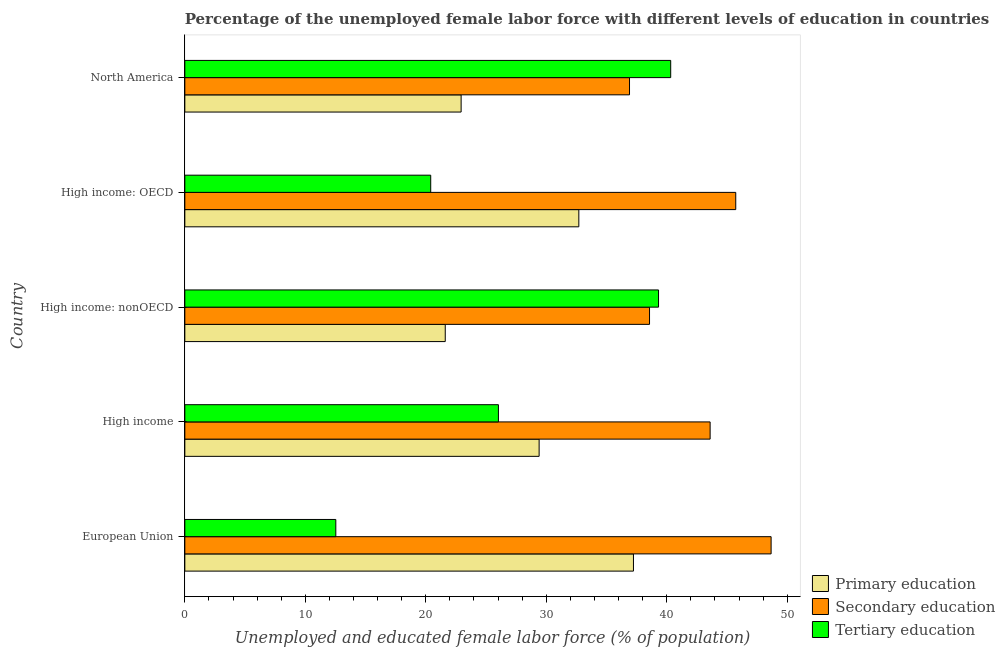How many different coloured bars are there?
Your answer should be compact. 3. Are the number of bars on each tick of the Y-axis equal?
Provide a succinct answer. Yes. How many bars are there on the 2nd tick from the top?
Provide a succinct answer. 3. How many bars are there on the 1st tick from the bottom?
Give a very brief answer. 3. What is the label of the 2nd group of bars from the top?
Your answer should be compact. High income: OECD. What is the percentage of female labor force who received secondary education in High income: OECD?
Offer a terse response. 45.73. Across all countries, what is the maximum percentage of female labor force who received tertiary education?
Offer a very short reply. 40.33. Across all countries, what is the minimum percentage of female labor force who received primary education?
Your response must be concise. 21.62. In which country was the percentage of female labor force who received secondary education maximum?
Your response must be concise. European Union. What is the total percentage of female labor force who received primary education in the graph?
Provide a short and direct response. 143.89. What is the difference between the percentage of female labor force who received primary education in European Union and that in High income: OECD?
Offer a terse response. 4.54. What is the difference between the percentage of female labor force who received tertiary education in High income and the percentage of female labor force who received secondary education in European Union?
Your answer should be very brief. -22.63. What is the average percentage of female labor force who received secondary education per country?
Your answer should be very brief. 42.69. What is the difference between the percentage of female labor force who received tertiary education and percentage of female labor force who received secondary education in European Union?
Your answer should be very brief. -36.13. What is the ratio of the percentage of female labor force who received tertiary education in European Union to that in High income: OECD?
Offer a terse response. 0.61. Is the percentage of female labor force who received secondary education in High income less than that in High income: OECD?
Provide a succinct answer. Yes. Is the difference between the percentage of female labor force who received primary education in High income and High income: nonOECD greater than the difference between the percentage of female labor force who received tertiary education in High income and High income: nonOECD?
Provide a short and direct response. Yes. What is the difference between the highest and the second highest percentage of female labor force who received secondary education?
Provide a short and direct response. 2.94. What is the difference between the highest and the lowest percentage of female labor force who received tertiary education?
Your response must be concise. 27.8. Is the sum of the percentage of female labor force who received primary education in High income and North America greater than the maximum percentage of female labor force who received secondary education across all countries?
Ensure brevity in your answer.  Yes. What does the 3rd bar from the bottom in High income: OECD represents?
Make the answer very short. Tertiary education. Is it the case that in every country, the sum of the percentage of female labor force who received primary education and percentage of female labor force who received secondary education is greater than the percentage of female labor force who received tertiary education?
Your answer should be compact. Yes. Are all the bars in the graph horizontal?
Give a very brief answer. Yes. What is the difference between two consecutive major ticks on the X-axis?
Offer a terse response. 10. Does the graph contain any zero values?
Keep it short and to the point. No. Does the graph contain grids?
Keep it short and to the point. No. Where does the legend appear in the graph?
Your response must be concise. Bottom right. What is the title of the graph?
Provide a succinct answer. Percentage of the unemployed female labor force with different levels of education in countries. What is the label or title of the X-axis?
Provide a succinct answer. Unemployed and educated female labor force (% of population). What is the label or title of the Y-axis?
Your answer should be compact. Country. What is the Unemployed and educated female labor force (% of population) in Primary education in European Union?
Provide a succinct answer. 37.24. What is the Unemployed and educated female labor force (% of population) in Secondary education in European Union?
Your answer should be compact. 48.66. What is the Unemployed and educated female labor force (% of population) of Tertiary education in European Union?
Ensure brevity in your answer.  12.53. What is the Unemployed and educated female labor force (% of population) of Primary education in High income?
Your response must be concise. 29.41. What is the Unemployed and educated female labor force (% of population) of Secondary education in High income?
Offer a very short reply. 43.6. What is the Unemployed and educated female labor force (% of population) of Tertiary education in High income?
Give a very brief answer. 26.03. What is the Unemployed and educated female labor force (% of population) in Primary education in High income: nonOECD?
Ensure brevity in your answer.  21.62. What is the Unemployed and educated female labor force (% of population) in Secondary education in High income: nonOECD?
Offer a terse response. 38.57. What is the Unemployed and educated female labor force (% of population) in Tertiary education in High income: nonOECD?
Offer a very short reply. 39.32. What is the Unemployed and educated female labor force (% of population) of Primary education in High income: OECD?
Make the answer very short. 32.7. What is the Unemployed and educated female labor force (% of population) in Secondary education in High income: OECD?
Give a very brief answer. 45.73. What is the Unemployed and educated female labor force (% of population) of Tertiary education in High income: OECD?
Provide a short and direct response. 20.41. What is the Unemployed and educated female labor force (% of population) in Primary education in North America?
Give a very brief answer. 22.93. What is the Unemployed and educated female labor force (% of population) of Secondary education in North America?
Provide a succinct answer. 36.91. What is the Unemployed and educated female labor force (% of population) of Tertiary education in North America?
Ensure brevity in your answer.  40.33. Across all countries, what is the maximum Unemployed and educated female labor force (% of population) of Primary education?
Ensure brevity in your answer.  37.24. Across all countries, what is the maximum Unemployed and educated female labor force (% of population) of Secondary education?
Your response must be concise. 48.66. Across all countries, what is the maximum Unemployed and educated female labor force (% of population) of Tertiary education?
Your response must be concise. 40.33. Across all countries, what is the minimum Unemployed and educated female labor force (% of population) in Primary education?
Ensure brevity in your answer.  21.62. Across all countries, what is the minimum Unemployed and educated female labor force (% of population) in Secondary education?
Your response must be concise. 36.91. Across all countries, what is the minimum Unemployed and educated female labor force (% of population) of Tertiary education?
Offer a terse response. 12.53. What is the total Unemployed and educated female labor force (% of population) of Primary education in the graph?
Keep it short and to the point. 143.89. What is the total Unemployed and educated female labor force (% of population) in Secondary education in the graph?
Keep it short and to the point. 213.47. What is the total Unemployed and educated female labor force (% of population) of Tertiary education in the graph?
Ensure brevity in your answer.  138.61. What is the difference between the Unemployed and educated female labor force (% of population) of Primary education in European Union and that in High income?
Provide a short and direct response. 7.83. What is the difference between the Unemployed and educated female labor force (% of population) in Secondary education in European Union and that in High income?
Your answer should be very brief. 5.06. What is the difference between the Unemployed and educated female labor force (% of population) of Tertiary education in European Union and that in High income?
Your response must be concise. -13.5. What is the difference between the Unemployed and educated female labor force (% of population) of Primary education in European Union and that in High income: nonOECD?
Your answer should be compact. 15.62. What is the difference between the Unemployed and educated female labor force (% of population) in Secondary education in European Union and that in High income: nonOECD?
Your response must be concise. 10.09. What is the difference between the Unemployed and educated female labor force (% of population) in Tertiary education in European Union and that in High income: nonOECD?
Offer a terse response. -26.79. What is the difference between the Unemployed and educated female labor force (% of population) of Primary education in European Union and that in High income: OECD?
Offer a terse response. 4.53. What is the difference between the Unemployed and educated female labor force (% of population) in Secondary education in European Union and that in High income: OECD?
Your response must be concise. 2.94. What is the difference between the Unemployed and educated female labor force (% of population) of Tertiary education in European Union and that in High income: OECD?
Ensure brevity in your answer.  -7.88. What is the difference between the Unemployed and educated female labor force (% of population) of Primary education in European Union and that in North America?
Offer a very short reply. 14.3. What is the difference between the Unemployed and educated female labor force (% of population) of Secondary education in European Union and that in North America?
Offer a very short reply. 11.75. What is the difference between the Unemployed and educated female labor force (% of population) in Tertiary education in European Union and that in North America?
Your response must be concise. -27.8. What is the difference between the Unemployed and educated female labor force (% of population) in Primary education in High income and that in High income: nonOECD?
Your answer should be very brief. 7.79. What is the difference between the Unemployed and educated female labor force (% of population) in Secondary education in High income and that in High income: nonOECD?
Give a very brief answer. 5.03. What is the difference between the Unemployed and educated female labor force (% of population) of Tertiary education in High income and that in High income: nonOECD?
Provide a short and direct response. -13.29. What is the difference between the Unemployed and educated female labor force (% of population) in Primary education in High income and that in High income: OECD?
Your response must be concise. -3.29. What is the difference between the Unemployed and educated female labor force (% of population) in Secondary education in High income and that in High income: OECD?
Offer a terse response. -2.13. What is the difference between the Unemployed and educated female labor force (% of population) of Tertiary education in High income and that in High income: OECD?
Provide a short and direct response. 5.62. What is the difference between the Unemployed and educated female labor force (% of population) in Primary education in High income and that in North America?
Offer a very short reply. 6.47. What is the difference between the Unemployed and educated female labor force (% of population) in Secondary education in High income and that in North America?
Offer a terse response. 6.69. What is the difference between the Unemployed and educated female labor force (% of population) of Tertiary education in High income and that in North America?
Ensure brevity in your answer.  -14.3. What is the difference between the Unemployed and educated female labor force (% of population) in Primary education in High income: nonOECD and that in High income: OECD?
Your answer should be very brief. -11.09. What is the difference between the Unemployed and educated female labor force (% of population) in Secondary education in High income: nonOECD and that in High income: OECD?
Your answer should be compact. -7.16. What is the difference between the Unemployed and educated female labor force (% of population) in Tertiary education in High income: nonOECD and that in High income: OECD?
Ensure brevity in your answer.  18.91. What is the difference between the Unemployed and educated female labor force (% of population) in Primary education in High income: nonOECD and that in North America?
Make the answer very short. -1.32. What is the difference between the Unemployed and educated female labor force (% of population) of Secondary education in High income: nonOECD and that in North America?
Offer a terse response. 1.66. What is the difference between the Unemployed and educated female labor force (% of population) in Tertiary education in High income: nonOECD and that in North America?
Offer a very short reply. -1.01. What is the difference between the Unemployed and educated female labor force (% of population) of Primary education in High income: OECD and that in North America?
Give a very brief answer. 9.77. What is the difference between the Unemployed and educated female labor force (% of population) in Secondary education in High income: OECD and that in North America?
Offer a terse response. 8.82. What is the difference between the Unemployed and educated female labor force (% of population) in Tertiary education in High income: OECD and that in North America?
Offer a terse response. -19.92. What is the difference between the Unemployed and educated female labor force (% of population) of Primary education in European Union and the Unemployed and educated female labor force (% of population) of Secondary education in High income?
Make the answer very short. -6.36. What is the difference between the Unemployed and educated female labor force (% of population) of Primary education in European Union and the Unemployed and educated female labor force (% of population) of Tertiary education in High income?
Make the answer very short. 11.21. What is the difference between the Unemployed and educated female labor force (% of population) of Secondary education in European Union and the Unemployed and educated female labor force (% of population) of Tertiary education in High income?
Keep it short and to the point. 22.63. What is the difference between the Unemployed and educated female labor force (% of population) in Primary education in European Union and the Unemployed and educated female labor force (% of population) in Secondary education in High income: nonOECD?
Keep it short and to the point. -1.33. What is the difference between the Unemployed and educated female labor force (% of population) of Primary education in European Union and the Unemployed and educated female labor force (% of population) of Tertiary education in High income: nonOECD?
Provide a short and direct response. -2.08. What is the difference between the Unemployed and educated female labor force (% of population) in Secondary education in European Union and the Unemployed and educated female labor force (% of population) in Tertiary education in High income: nonOECD?
Keep it short and to the point. 9.34. What is the difference between the Unemployed and educated female labor force (% of population) of Primary education in European Union and the Unemployed and educated female labor force (% of population) of Secondary education in High income: OECD?
Provide a succinct answer. -8.49. What is the difference between the Unemployed and educated female labor force (% of population) of Primary education in European Union and the Unemployed and educated female labor force (% of population) of Tertiary education in High income: OECD?
Your answer should be very brief. 16.83. What is the difference between the Unemployed and educated female labor force (% of population) of Secondary education in European Union and the Unemployed and educated female labor force (% of population) of Tertiary education in High income: OECD?
Offer a very short reply. 28.25. What is the difference between the Unemployed and educated female labor force (% of population) of Primary education in European Union and the Unemployed and educated female labor force (% of population) of Secondary education in North America?
Make the answer very short. 0.33. What is the difference between the Unemployed and educated female labor force (% of population) of Primary education in European Union and the Unemployed and educated female labor force (% of population) of Tertiary education in North America?
Your answer should be very brief. -3.09. What is the difference between the Unemployed and educated female labor force (% of population) of Secondary education in European Union and the Unemployed and educated female labor force (% of population) of Tertiary education in North America?
Your answer should be very brief. 8.33. What is the difference between the Unemployed and educated female labor force (% of population) of Primary education in High income and the Unemployed and educated female labor force (% of population) of Secondary education in High income: nonOECD?
Make the answer very short. -9.16. What is the difference between the Unemployed and educated female labor force (% of population) in Primary education in High income and the Unemployed and educated female labor force (% of population) in Tertiary education in High income: nonOECD?
Give a very brief answer. -9.91. What is the difference between the Unemployed and educated female labor force (% of population) of Secondary education in High income and the Unemployed and educated female labor force (% of population) of Tertiary education in High income: nonOECD?
Provide a short and direct response. 4.28. What is the difference between the Unemployed and educated female labor force (% of population) of Primary education in High income and the Unemployed and educated female labor force (% of population) of Secondary education in High income: OECD?
Give a very brief answer. -16.32. What is the difference between the Unemployed and educated female labor force (% of population) in Primary education in High income and the Unemployed and educated female labor force (% of population) in Tertiary education in High income: OECD?
Offer a very short reply. 9. What is the difference between the Unemployed and educated female labor force (% of population) in Secondary education in High income and the Unemployed and educated female labor force (% of population) in Tertiary education in High income: OECD?
Provide a succinct answer. 23.19. What is the difference between the Unemployed and educated female labor force (% of population) in Primary education in High income and the Unemployed and educated female labor force (% of population) in Secondary education in North America?
Give a very brief answer. -7.5. What is the difference between the Unemployed and educated female labor force (% of population) of Primary education in High income and the Unemployed and educated female labor force (% of population) of Tertiary education in North America?
Offer a very short reply. -10.92. What is the difference between the Unemployed and educated female labor force (% of population) of Secondary education in High income and the Unemployed and educated female labor force (% of population) of Tertiary education in North America?
Your response must be concise. 3.27. What is the difference between the Unemployed and educated female labor force (% of population) in Primary education in High income: nonOECD and the Unemployed and educated female labor force (% of population) in Secondary education in High income: OECD?
Ensure brevity in your answer.  -24.11. What is the difference between the Unemployed and educated female labor force (% of population) in Primary education in High income: nonOECD and the Unemployed and educated female labor force (% of population) in Tertiary education in High income: OECD?
Provide a succinct answer. 1.21. What is the difference between the Unemployed and educated female labor force (% of population) of Secondary education in High income: nonOECD and the Unemployed and educated female labor force (% of population) of Tertiary education in High income: OECD?
Provide a succinct answer. 18.16. What is the difference between the Unemployed and educated female labor force (% of population) in Primary education in High income: nonOECD and the Unemployed and educated female labor force (% of population) in Secondary education in North America?
Give a very brief answer. -15.29. What is the difference between the Unemployed and educated female labor force (% of population) in Primary education in High income: nonOECD and the Unemployed and educated female labor force (% of population) in Tertiary education in North America?
Provide a short and direct response. -18.71. What is the difference between the Unemployed and educated female labor force (% of population) in Secondary education in High income: nonOECD and the Unemployed and educated female labor force (% of population) in Tertiary education in North America?
Make the answer very short. -1.76. What is the difference between the Unemployed and educated female labor force (% of population) of Primary education in High income: OECD and the Unemployed and educated female labor force (% of population) of Secondary education in North America?
Make the answer very short. -4.21. What is the difference between the Unemployed and educated female labor force (% of population) of Primary education in High income: OECD and the Unemployed and educated female labor force (% of population) of Tertiary education in North America?
Ensure brevity in your answer.  -7.63. What is the difference between the Unemployed and educated female labor force (% of population) in Secondary education in High income: OECD and the Unemployed and educated female labor force (% of population) in Tertiary education in North America?
Ensure brevity in your answer.  5.4. What is the average Unemployed and educated female labor force (% of population) of Primary education per country?
Offer a very short reply. 28.78. What is the average Unemployed and educated female labor force (% of population) of Secondary education per country?
Provide a short and direct response. 42.69. What is the average Unemployed and educated female labor force (% of population) of Tertiary education per country?
Offer a terse response. 27.72. What is the difference between the Unemployed and educated female labor force (% of population) in Primary education and Unemployed and educated female labor force (% of population) in Secondary education in European Union?
Provide a succinct answer. -11.43. What is the difference between the Unemployed and educated female labor force (% of population) of Primary education and Unemployed and educated female labor force (% of population) of Tertiary education in European Union?
Offer a very short reply. 24.7. What is the difference between the Unemployed and educated female labor force (% of population) in Secondary education and Unemployed and educated female labor force (% of population) in Tertiary education in European Union?
Keep it short and to the point. 36.13. What is the difference between the Unemployed and educated female labor force (% of population) of Primary education and Unemployed and educated female labor force (% of population) of Secondary education in High income?
Make the answer very short. -14.19. What is the difference between the Unemployed and educated female labor force (% of population) of Primary education and Unemployed and educated female labor force (% of population) of Tertiary education in High income?
Your answer should be very brief. 3.38. What is the difference between the Unemployed and educated female labor force (% of population) of Secondary education and Unemployed and educated female labor force (% of population) of Tertiary education in High income?
Your answer should be very brief. 17.57. What is the difference between the Unemployed and educated female labor force (% of population) in Primary education and Unemployed and educated female labor force (% of population) in Secondary education in High income: nonOECD?
Give a very brief answer. -16.95. What is the difference between the Unemployed and educated female labor force (% of population) of Primary education and Unemployed and educated female labor force (% of population) of Tertiary education in High income: nonOECD?
Offer a terse response. -17.7. What is the difference between the Unemployed and educated female labor force (% of population) of Secondary education and Unemployed and educated female labor force (% of population) of Tertiary education in High income: nonOECD?
Keep it short and to the point. -0.75. What is the difference between the Unemployed and educated female labor force (% of population) of Primary education and Unemployed and educated female labor force (% of population) of Secondary education in High income: OECD?
Make the answer very short. -13.02. What is the difference between the Unemployed and educated female labor force (% of population) of Primary education and Unemployed and educated female labor force (% of population) of Tertiary education in High income: OECD?
Your answer should be very brief. 12.29. What is the difference between the Unemployed and educated female labor force (% of population) in Secondary education and Unemployed and educated female labor force (% of population) in Tertiary education in High income: OECD?
Make the answer very short. 25.32. What is the difference between the Unemployed and educated female labor force (% of population) of Primary education and Unemployed and educated female labor force (% of population) of Secondary education in North America?
Give a very brief answer. -13.98. What is the difference between the Unemployed and educated female labor force (% of population) in Primary education and Unemployed and educated female labor force (% of population) in Tertiary education in North America?
Your answer should be very brief. -17.4. What is the difference between the Unemployed and educated female labor force (% of population) of Secondary education and Unemployed and educated female labor force (% of population) of Tertiary education in North America?
Provide a succinct answer. -3.42. What is the ratio of the Unemployed and educated female labor force (% of population) of Primary education in European Union to that in High income?
Keep it short and to the point. 1.27. What is the ratio of the Unemployed and educated female labor force (% of population) of Secondary education in European Union to that in High income?
Provide a short and direct response. 1.12. What is the ratio of the Unemployed and educated female labor force (% of population) in Tertiary education in European Union to that in High income?
Offer a very short reply. 0.48. What is the ratio of the Unemployed and educated female labor force (% of population) in Primary education in European Union to that in High income: nonOECD?
Your response must be concise. 1.72. What is the ratio of the Unemployed and educated female labor force (% of population) in Secondary education in European Union to that in High income: nonOECD?
Offer a very short reply. 1.26. What is the ratio of the Unemployed and educated female labor force (% of population) in Tertiary education in European Union to that in High income: nonOECD?
Your answer should be very brief. 0.32. What is the ratio of the Unemployed and educated female labor force (% of population) of Primary education in European Union to that in High income: OECD?
Ensure brevity in your answer.  1.14. What is the ratio of the Unemployed and educated female labor force (% of population) in Secondary education in European Union to that in High income: OECD?
Make the answer very short. 1.06. What is the ratio of the Unemployed and educated female labor force (% of population) of Tertiary education in European Union to that in High income: OECD?
Make the answer very short. 0.61. What is the ratio of the Unemployed and educated female labor force (% of population) of Primary education in European Union to that in North America?
Ensure brevity in your answer.  1.62. What is the ratio of the Unemployed and educated female labor force (% of population) of Secondary education in European Union to that in North America?
Keep it short and to the point. 1.32. What is the ratio of the Unemployed and educated female labor force (% of population) of Tertiary education in European Union to that in North America?
Your answer should be compact. 0.31. What is the ratio of the Unemployed and educated female labor force (% of population) of Primary education in High income to that in High income: nonOECD?
Give a very brief answer. 1.36. What is the ratio of the Unemployed and educated female labor force (% of population) of Secondary education in High income to that in High income: nonOECD?
Keep it short and to the point. 1.13. What is the ratio of the Unemployed and educated female labor force (% of population) of Tertiary education in High income to that in High income: nonOECD?
Offer a very short reply. 0.66. What is the ratio of the Unemployed and educated female labor force (% of population) in Primary education in High income to that in High income: OECD?
Your answer should be very brief. 0.9. What is the ratio of the Unemployed and educated female labor force (% of population) of Secondary education in High income to that in High income: OECD?
Your answer should be compact. 0.95. What is the ratio of the Unemployed and educated female labor force (% of population) in Tertiary education in High income to that in High income: OECD?
Provide a short and direct response. 1.28. What is the ratio of the Unemployed and educated female labor force (% of population) of Primary education in High income to that in North America?
Offer a terse response. 1.28. What is the ratio of the Unemployed and educated female labor force (% of population) in Secondary education in High income to that in North America?
Your answer should be very brief. 1.18. What is the ratio of the Unemployed and educated female labor force (% of population) of Tertiary education in High income to that in North America?
Make the answer very short. 0.65. What is the ratio of the Unemployed and educated female labor force (% of population) in Primary education in High income: nonOECD to that in High income: OECD?
Keep it short and to the point. 0.66. What is the ratio of the Unemployed and educated female labor force (% of population) of Secondary education in High income: nonOECD to that in High income: OECD?
Your response must be concise. 0.84. What is the ratio of the Unemployed and educated female labor force (% of population) in Tertiary education in High income: nonOECD to that in High income: OECD?
Provide a short and direct response. 1.93. What is the ratio of the Unemployed and educated female labor force (% of population) of Primary education in High income: nonOECD to that in North America?
Offer a very short reply. 0.94. What is the ratio of the Unemployed and educated female labor force (% of population) of Secondary education in High income: nonOECD to that in North America?
Ensure brevity in your answer.  1.04. What is the ratio of the Unemployed and educated female labor force (% of population) in Tertiary education in High income: nonOECD to that in North America?
Your answer should be very brief. 0.97. What is the ratio of the Unemployed and educated female labor force (% of population) of Primary education in High income: OECD to that in North America?
Your answer should be compact. 1.43. What is the ratio of the Unemployed and educated female labor force (% of population) in Secondary education in High income: OECD to that in North America?
Give a very brief answer. 1.24. What is the ratio of the Unemployed and educated female labor force (% of population) of Tertiary education in High income: OECD to that in North America?
Your answer should be very brief. 0.51. What is the difference between the highest and the second highest Unemployed and educated female labor force (% of population) of Primary education?
Offer a terse response. 4.53. What is the difference between the highest and the second highest Unemployed and educated female labor force (% of population) in Secondary education?
Offer a terse response. 2.94. What is the difference between the highest and the second highest Unemployed and educated female labor force (% of population) of Tertiary education?
Your answer should be very brief. 1.01. What is the difference between the highest and the lowest Unemployed and educated female labor force (% of population) in Primary education?
Offer a very short reply. 15.62. What is the difference between the highest and the lowest Unemployed and educated female labor force (% of population) of Secondary education?
Your response must be concise. 11.75. What is the difference between the highest and the lowest Unemployed and educated female labor force (% of population) of Tertiary education?
Provide a short and direct response. 27.8. 